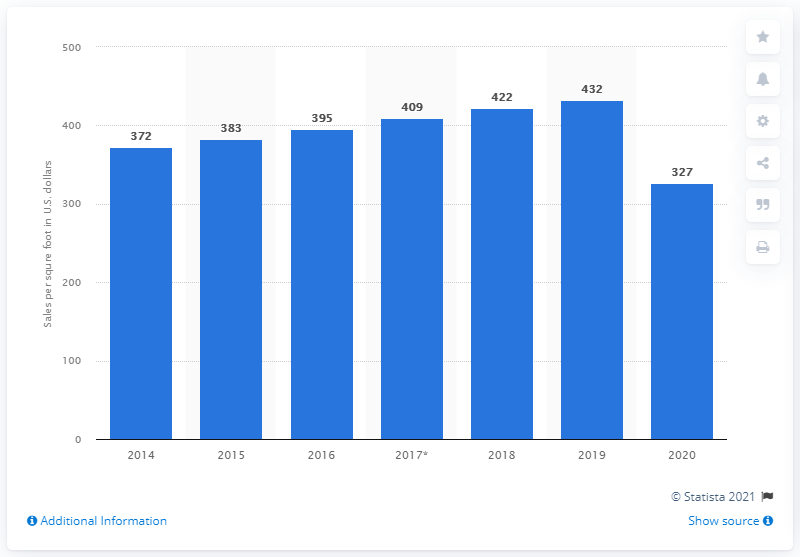Give some essential details in this illustration. In 2020, the average sales per square foot of Ross Stores was 327. The average sales per square foot of Ross Stores a year earlier was 432. 